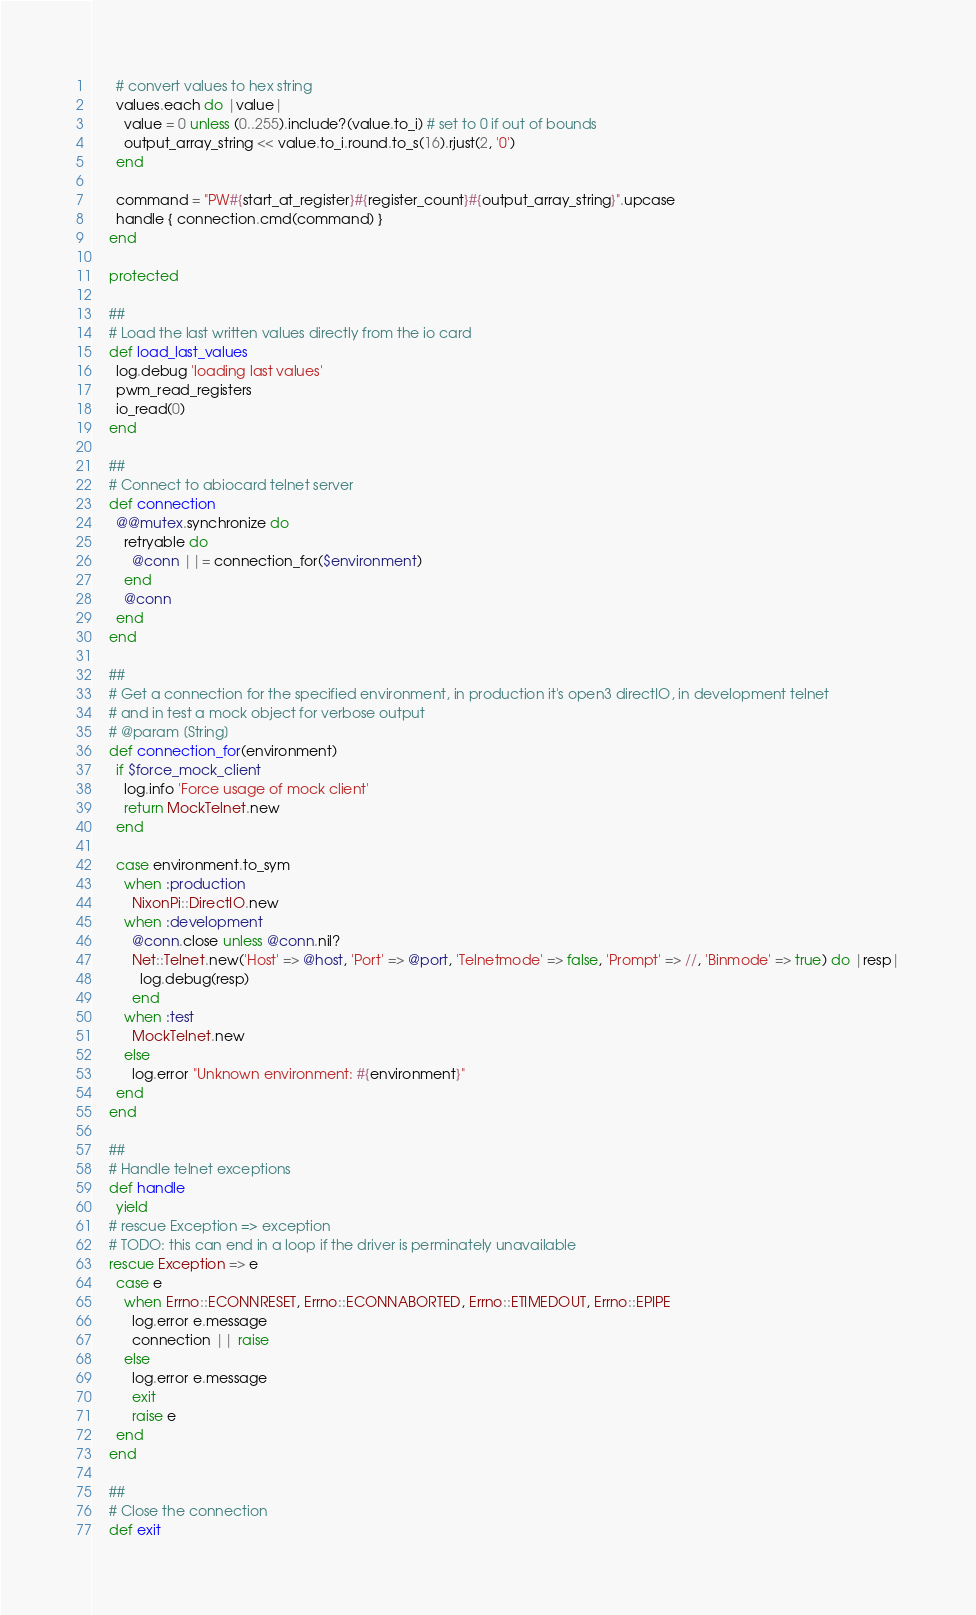<code> <loc_0><loc_0><loc_500><loc_500><_Ruby_>      # convert values to hex string
      values.each do |value|
        value = 0 unless (0..255).include?(value.to_i) # set to 0 if out of bounds
        output_array_string << value.to_i.round.to_s(16).rjust(2, '0')
      end

      command = "PW#{start_at_register}#{register_count}#{output_array_string}".upcase
      handle { connection.cmd(command) }
    end

    protected

    ##
    # Load the last written values directly from the io card
    def load_last_values
      log.debug 'loading last values'
      pwm_read_registers
      io_read(0)
    end

    ##
    # Connect to abiocard telnet server
    def connection
      @@mutex.synchronize do
        retryable do
          @conn ||= connection_for($environment)
        end
        @conn
      end
    end

    ##
    # Get a connection for the specified environment, in production it's open3 directIO, in development telnet
    # and in test a mock object for verbose output
    # @param [String]
    def connection_for(environment)
      if $force_mock_client
        log.info 'Force usage of mock client'
        return MockTelnet.new
      end

      case environment.to_sym
        when :production
          NixonPi::DirectIO.new
        when :development
          @conn.close unless @conn.nil?
          Net::Telnet.new('Host' => @host, 'Port' => @port, 'Telnetmode' => false, 'Prompt' => //, 'Binmode' => true) do |resp|
            log.debug(resp)
          end
        when :test
          MockTelnet.new
        else
          log.error "Unknown environment: #{environment}"
      end
    end

    ##
    # Handle telnet exceptions
    def handle
      yield
    # rescue Exception => exception
    # TODO: this can end in a loop if the driver is perminately unavailable
    rescue Exception => e
      case e
        when Errno::ECONNRESET, Errno::ECONNABORTED, Errno::ETIMEDOUT, Errno::EPIPE
          log.error e.message
          connection || raise
        else
          log.error e.message
          exit
          raise e
      end
    end

    ##
    # Close the connection
    def exit</code> 